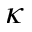<formula> <loc_0><loc_0><loc_500><loc_500>\kappa</formula> 